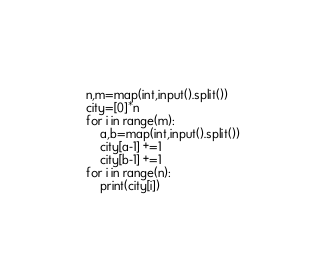<code> <loc_0><loc_0><loc_500><loc_500><_Python_>n,m=map(int,input().split())
city=[0]*n
for i in range(m):
    a,b=map(int,input().split())
    city[a-1] +=1
    city[b-1] +=1
for i in range(n):
    print(city[i])</code> 